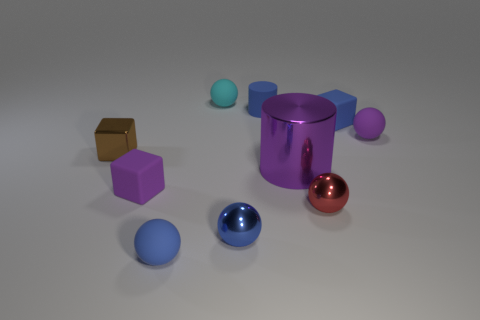Is there any other thing that is the same size as the shiny cylinder?
Ensure brevity in your answer.  No. There is a metal object that is both to the right of the tiny brown metallic cube and behind the tiny red ball; how big is it?
Give a very brief answer. Large. What is the color of the small shiny block?
Offer a terse response. Brown. How many brown shiny things are there?
Your answer should be very brief. 1. How many tiny rubber cubes have the same color as the big metallic cylinder?
Ensure brevity in your answer.  1. There is a blue shiny object in front of the tiny matte cylinder; does it have the same shape as the metal object to the left of the tiny cyan object?
Your answer should be very brief. No. There is a block behind the tiny purple matte object that is to the right of the blue thing that is behind the blue matte block; what is its color?
Ensure brevity in your answer.  Blue. There is a tiny matte sphere that is on the right side of the tiny cyan matte object; what color is it?
Your response must be concise. Purple. There is a metallic block that is the same size as the purple sphere; what color is it?
Offer a very short reply. Brown. Does the red sphere have the same size as the blue matte sphere?
Your answer should be very brief. Yes. 